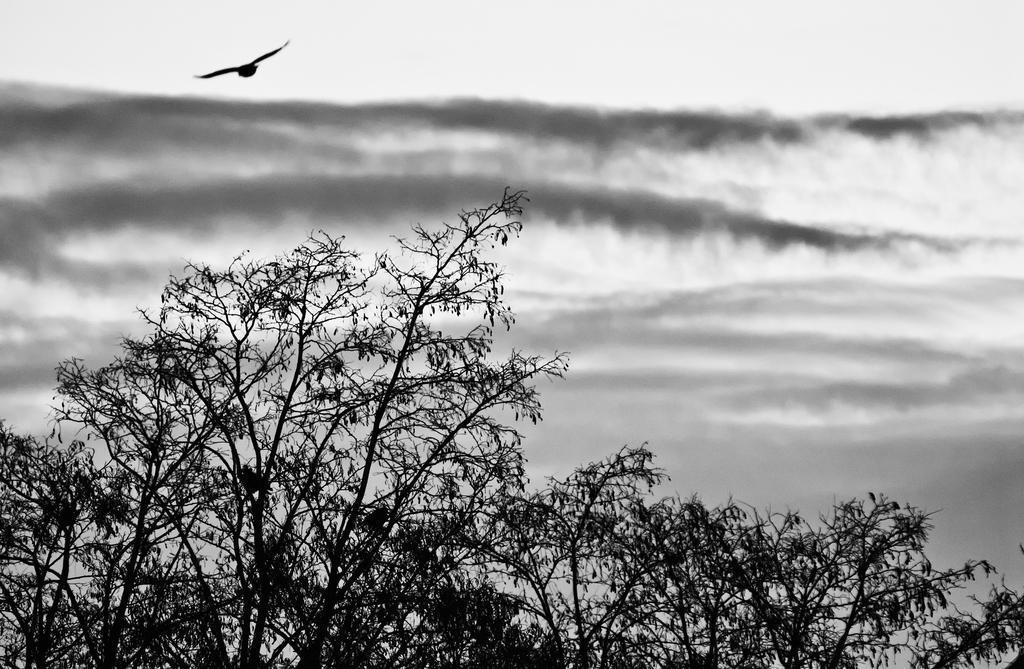Please provide a concise description of this image. In this image we an see a black and white picture of trees, water and a bird flying on the sky. 